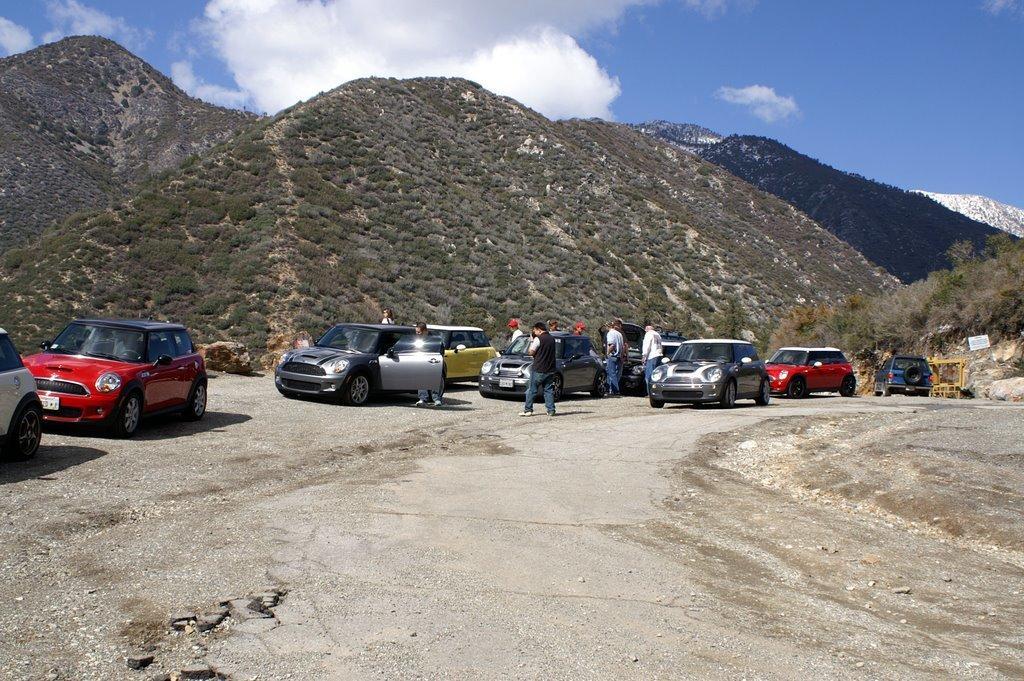Can you describe this image briefly? In this image we can see some cars parked on the road. We can also see few people standing. In the background there are hills and also mountains. Sky is also visible with clouds. 